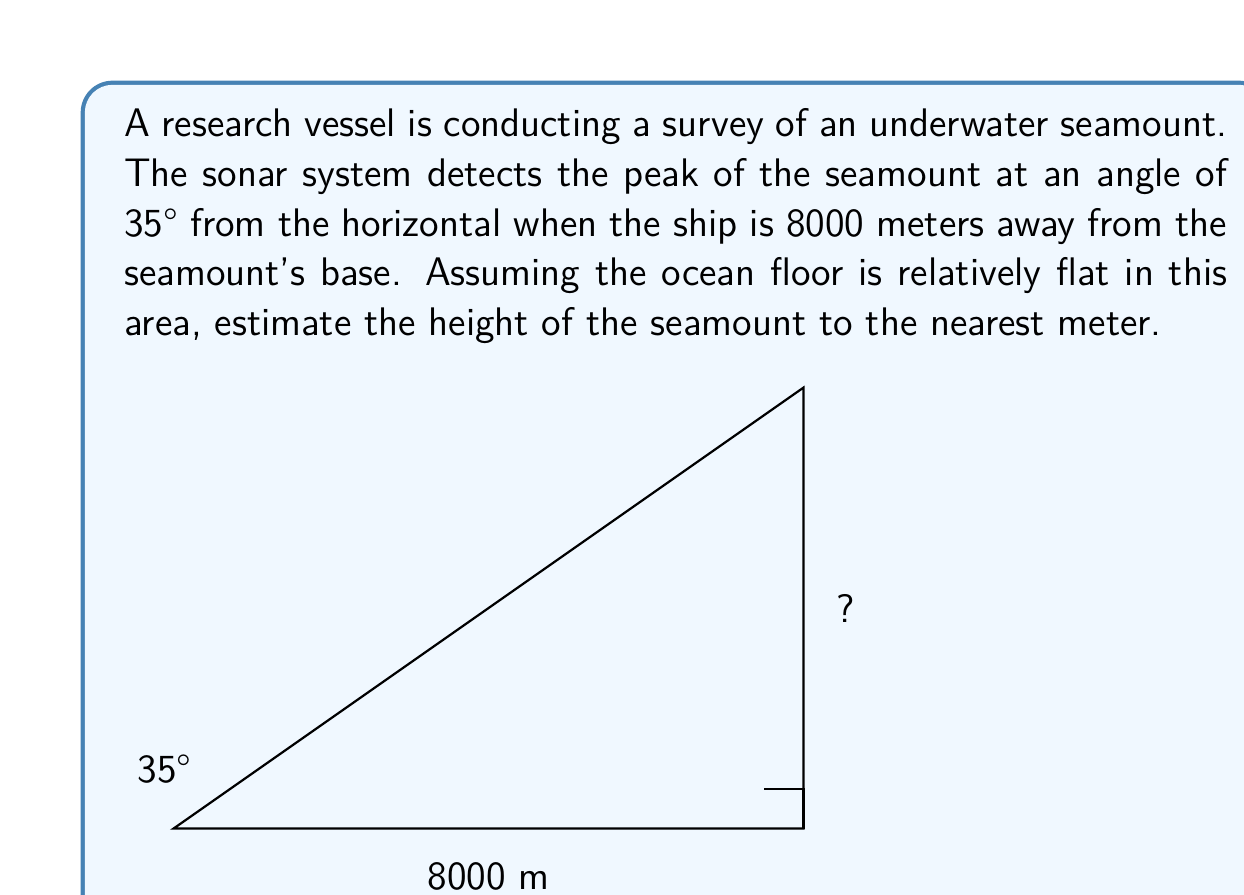Teach me how to tackle this problem. To solve this problem, we can use trigonometry, specifically the tangent function. Let's break it down step-by-step:

1) In a right-angled triangle, tangent of an angle is the ratio of the opposite side to the adjacent side.

2) In this case:
   - The angle is 35°
   - The adjacent side is the distance from the ship to the base of the seamount (8000 m)
   - The opposite side is the height of the seamount we're trying to find

3) We can express this relationship as:

   $$\tan(35°) = \frac{\text{height}}{\text{8000}}$$

4) To find the height, we multiply both sides by 8000:

   $$\text{height} = 8000 \cdot \tan(35°)$$

5) Now, let's calculate:
   
   $$\text{height} = 8000 \cdot \tan(35°)$$
   $$= 8000 \cdot 0.7002075$$
   $$= 5601.66 \text{ meters}$$

6) Rounding to the nearest meter as requested:

   $$\text{height} \approx 5602 \text{ meters}$$

Therefore, the estimated height of the seamount is 5602 meters.
Answer: 5602 meters 